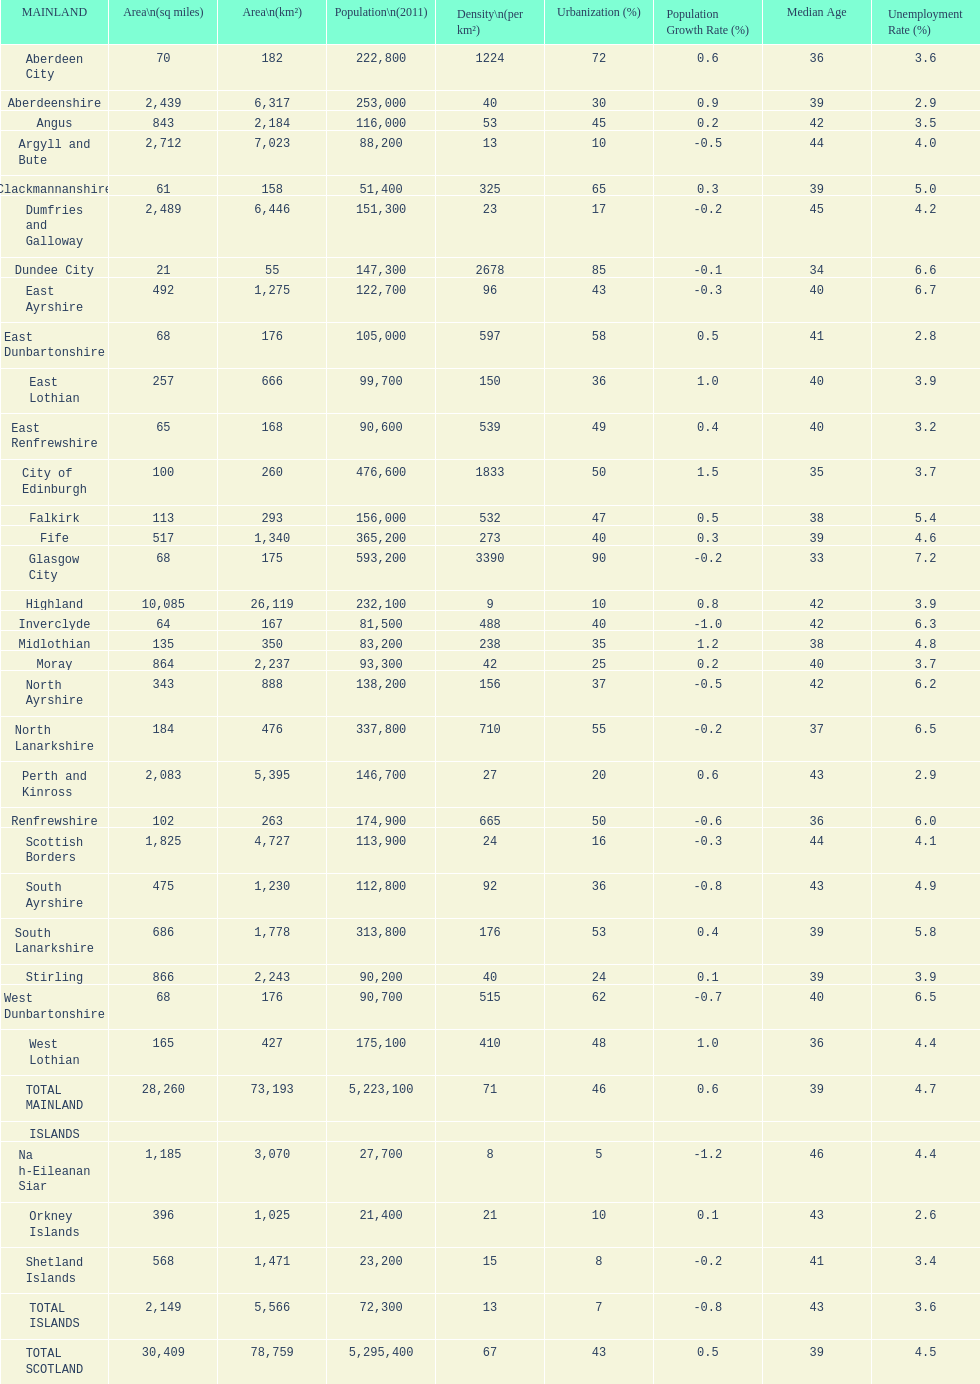What is the difference in square miles from angus and fife? 326. 